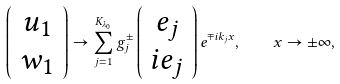<formula> <loc_0><loc_0><loc_500><loc_500>\left ( \begin{array} { c } { u } _ { 1 } \\ { w } _ { 1 } \end{array} \right ) \rightarrow \sum _ { j = 1 } ^ { K _ { \lambda _ { 0 } } } g _ { j } ^ { \pm } \left ( \begin{array} { c c } { e } _ { j } \\ i { e } _ { j } \end{array} \right ) e ^ { \mp i k _ { j } x } , \quad x \to \pm \infty ,</formula> 